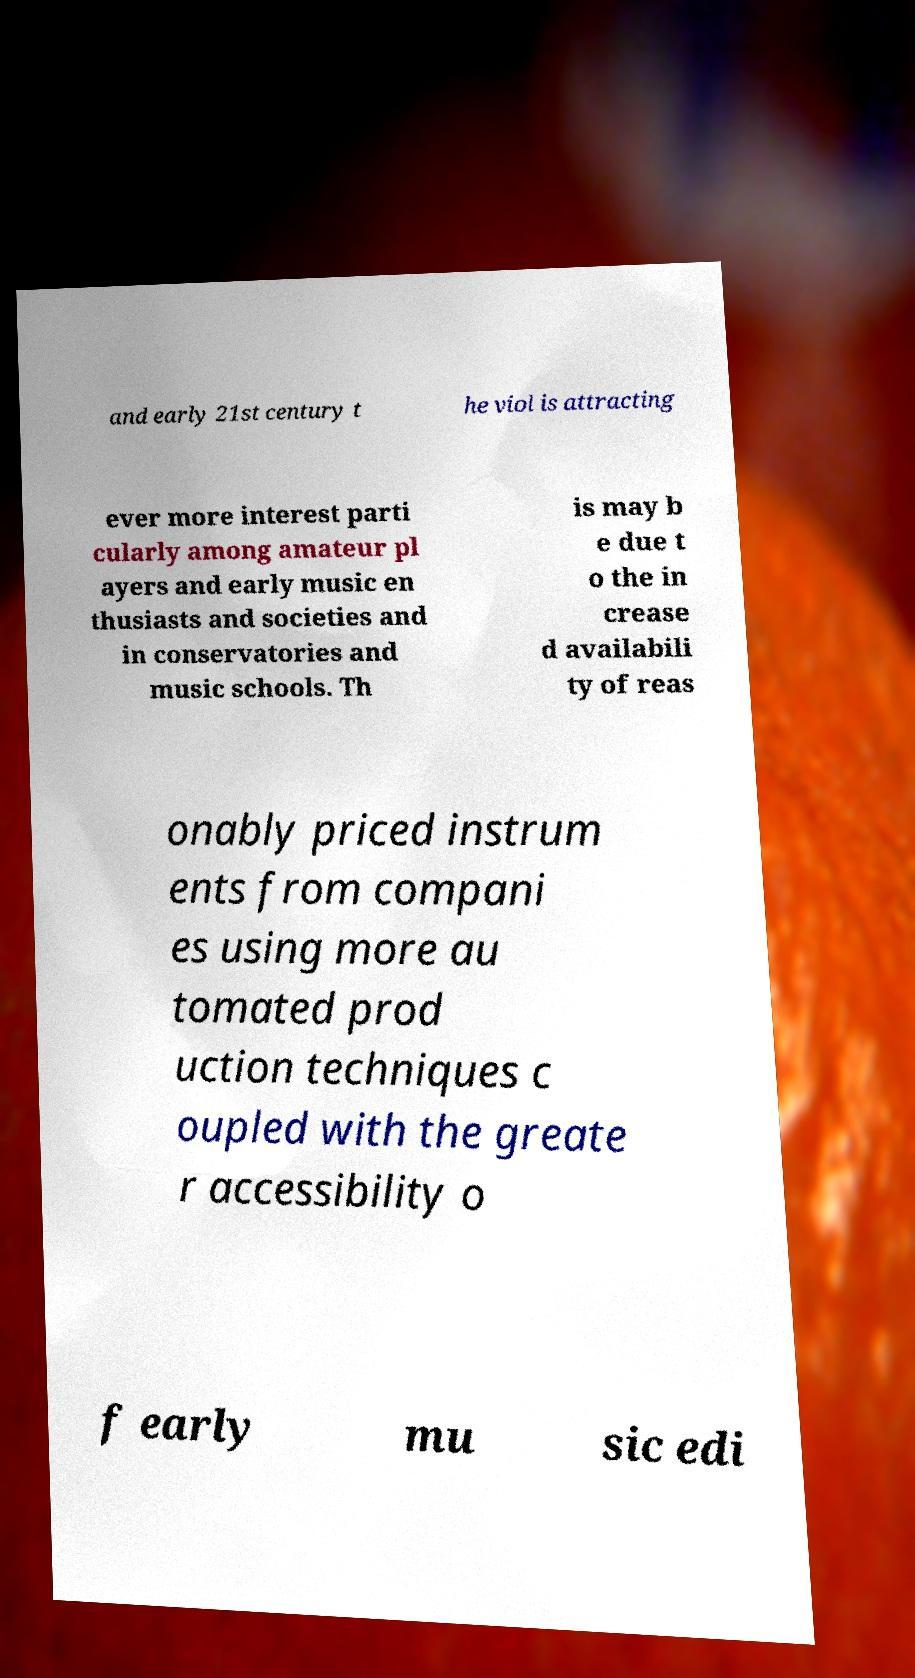What messages or text are displayed in this image? I need them in a readable, typed format. and early 21st century t he viol is attracting ever more interest parti cularly among amateur pl ayers and early music en thusiasts and societies and in conservatories and music schools. Th is may b e due t o the in crease d availabili ty of reas onably priced instrum ents from compani es using more au tomated prod uction techniques c oupled with the greate r accessibility o f early mu sic edi 